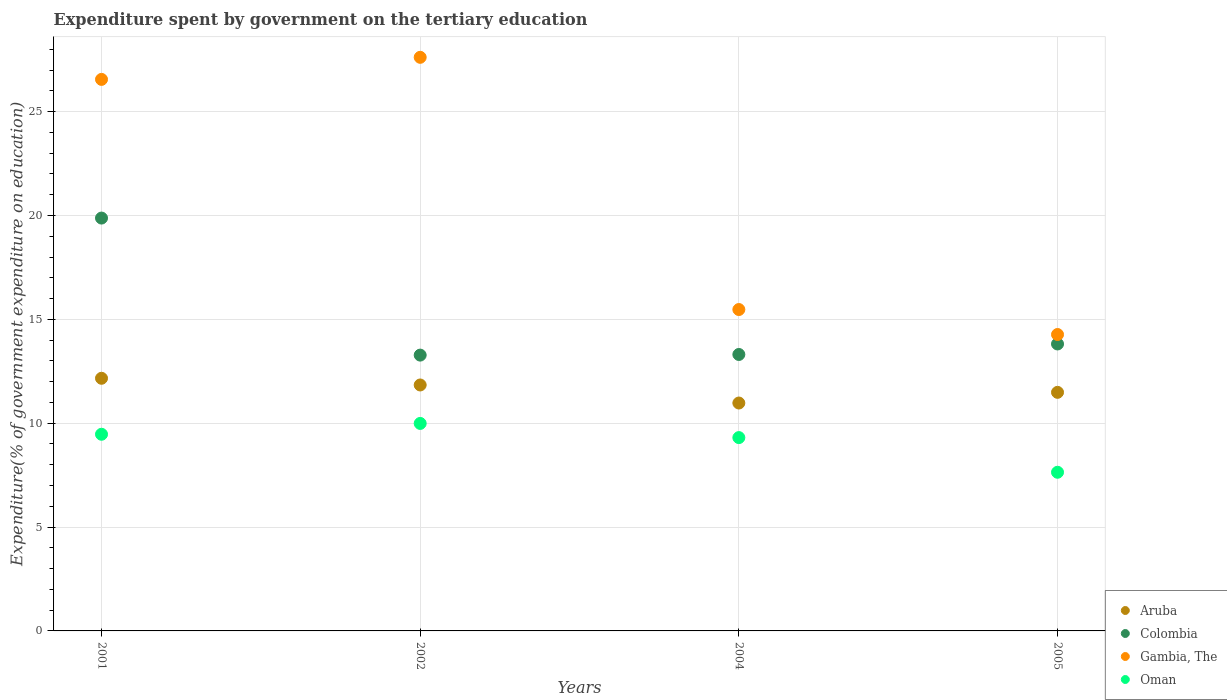How many different coloured dotlines are there?
Ensure brevity in your answer.  4. Is the number of dotlines equal to the number of legend labels?
Offer a terse response. Yes. What is the expenditure spent by government on the tertiary education in Colombia in 2002?
Keep it short and to the point. 13.28. Across all years, what is the maximum expenditure spent by government on the tertiary education in Gambia, The?
Offer a very short reply. 27.61. Across all years, what is the minimum expenditure spent by government on the tertiary education in Colombia?
Make the answer very short. 13.28. In which year was the expenditure spent by government on the tertiary education in Colombia minimum?
Make the answer very short. 2002. What is the total expenditure spent by government on the tertiary education in Colombia in the graph?
Ensure brevity in your answer.  60.27. What is the difference between the expenditure spent by government on the tertiary education in Gambia, The in 2001 and that in 2002?
Provide a succinct answer. -1.06. What is the difference between the expenditure spent by government on the tertiary education in Gambia, The in 2004 and the expenditure spent by government on the tertiary education in Colombia in 2001?
Your answer should be compact. -4.4. What is the average expenditure spent by government on the tertiary education in Colombia per year?
Make the answer very short. 15.07. In the year 2005, what is the difference between the expenditure spent by government on the tertiary education in Aruba and expenditure spent by government on the tertiary education in Gambia, The?
Give a very brief answer. -2.78. In how many years, is the expenditure spent by government on the tertiary education in Aruba greater than 14 %?
Your response must be concise. 0. What is the ratio of the expenditure spent by government on the tertiary education in Colombia in 2004 to that in 2005?
Make the answer very short. 0.96. Is the expenditure spent by government on the tertiary education in Gambia, The in 2004 less than that in 2005?
Offer a very short reply. No. Is the difference between the expenditure spent by government on the tertiary education in Aruba in 2001 and 2004 greater than the difference between the expenditure spent by government on the tertiary education in Gambia, The in 2001 and 2004?
Your answer should be compact. No. What is the difference between the highest and the second highest expenditure spent by government on the tertiary education in Aruba?
Give a very brief answer. 0.32. What is the difference between the highest and the lowest expenditure spent by government on the tertiary education in Oman?
Make the answer very short. 2.35. Is the sum of the expenditure spent by government on the tertiary education in Oman in 2001 and 2002 greater than the maximum expenditure spent by government on the tertiary education in Colombia across all years?
Keep it short and to the point. No. Is it the case that in every year, the sum of the expenditure spent by government on the tertiary education in Colombia and expenditure spent by government on the tertiary education in Oman  is greater than the sum of expenditure spent by government on the tertiary education in Gambia, The and expenditure spent by government on the tertiary education in Aruba?
Your answer should be very brief. No. Is it the case that in every year, the sum of the expenditure spent by government on the tertiary education in Colombia and expenditure spent by government on the tertiary education in Gambia, The  is greater than the expenditure spent by government on the tertiary education in Aruba?
Your answer should be compact. Yes. Does the expenditure spent by government on the tertiary education in Colombia monotonically increase over the years?
Give a very brief answer. No. Is the expenditure spent by government on the tertiary education in Gambia, The strictly less than the expenditure spent by government on the tertiary education in Oman over the years?
Keep it short and to the point. No. How many dotlines are there?
Provide a short and direct response. 4. How many years are there in the graph?
Offer a very short reply. 4. Are the values on the major ticks of Y-axis written in scientific E-notation?
Provide a succinct answer. No. Does the graph contain any zero values?
Offer a terse response. No. Where does the legend appear in the graph?
Your answer should be very brief. Bottom right. How many legend labels are there?
Your response must be concise. 4. What is the title of the graph?
Provide a short and direct response. Expenditure spent by government on the tertiary education. Does "Mali" appear as one of the legend labels in the graph?
Keep it short and to the point. No. What is the label or title of the Y-axis?
Offer a terse response. Expenditure(% of government expenditure on education). What is the Expenditure(% of government expenditure on education) in Aruba in 2001?
Your response must be concise. 12.16. What is the Expenditure(% of government expenditure on education) of Colombia in 2001?
Provide a short and direct response. 19.87. What is the Expenditure(% of government expenditure on education) in Gambia, The in 2001?
Your answer should be very brief. 26.55. What is the Expenditure(% of government expenditure on education) in Oman in 2001?
Offer a very short reply. 9.47. What is the Expenditure(% of government expenditure on education) of Aruba in 2002?
Offer a very short reply. 11.84. What is the Expenditure(% of government expenditure on education) of Colombia in 2002?
Provide a succinct answer. 13.28. What is the Expenditure(% of government expenditure on education) of Gambia, The in 2002?
Provide a short and direct response. 27.61. What is the Expenditure(% of government expenditure on education) of Oman in 2002?
Your answer should be compact. 9.99. What is the Expenditure(% of government expenditure on education) of Aruba in 2004?
Your answer should be compact. 10.97. What is the Expenditure(% of government expenditure on education) in Colombia in 2004?
Ensure brevity in your answer.  13.31. What is the Expenditure(% of government expenditure on education) in Gambia, The in 2004?
Offer a terse response. 15.47. What is the Expenditure(% of government expenditure on education) of Oman in 2004?
Provide a succinct answer. 9.31. What is the Expenditure(% of government expenditure on education) of Aruba in 2005?
Keep it short and to the point. 11.49. What is the Expenditure(% of government expenditure on education) of Colombia in 2005?
Provide a short and direct response. 13.81. What is the Expenditure(% of government expenditure on education) in Gambia, The in 2005?
Offer a very short reply. 14.27. What is the Expenditure(% of government expenditure on education) in Oman in 2005?
Ensure brevity in your answer.  7.64. Across all years, what is the maximum Expenditure(% of government expenditure on education) in Aruba?
Ensure brevity in your answer.  12.16. Across all years, what is the maximum Expenditure(% of government expenditure on education) of Colombia?
Give a very brief answer. 19.87. Across all years, what is the maximum Expenditure(% of government expenditure on education) of Gambia, The?
Give a very brief answer. 27.61. Across all years, what is the maximum Expenditure(% of government expenditure on education) in Oman?
Keep it short and to the point. 9.99. Across all years, what is the minimum Expenditure(% of government expenditure on education) of Aruba?
Provide a short and direct response. 10.97. Across all years, what is the minimum Expenditure(% of government expenditure on education) in Colombia?
Your response must be concise. 13.28. Across all years, what is the minimum Expenditure(% of government expenditure on education) of Gambia, The?
Your answer should be compact. 14.27. Across all years, what is the minimum Expenditure(% of government expenditure on education) of Oman?
Provide a short and direct response. 7.64. What is the total Expenditure(% of government expenditure on education) of Aruba in the graph?
Give a very brief answer. 46.46. What is the total Expenditure(% of government expenditure on education) of Colombia in the graph?
Provide a short and direct response. 60.27. What is the total Expenditure(% of government expenditure on education) of Gambia, The in the graph?
Your answer should be very brief. 83.91. What is the total Expenditure(% of government expenditure on education) in Oman in the graph?
Ensure brevity in your answer.  36.4. What is the difference between the Expenditure(% of government expenditure on education) in Aruba in 2001 and that in 2002?
Provide a succinct answer. 0.32. What is the difference between the Expenditure(% of government expenditure on education) of Colombia in 2001 and that in 2002?
Your answer should be very brief. 6.6. What is the difference between the Expenditure(% of government expenditure on education) in Gambia, The in 2001 and that in 2002?
Ensure brevity in your answer.  -1.06. What is the difference between the Expenditure(% of government expenditure on education) of Oman in 2001 and that in 2002?
Offer a very short reply. -0.52. What is the difference between the Expenditure(% of government expenditure on education) in Aruba in 2001 and that in 2004?
Keep it short and to the point. 1.19. What is the difference between the Expenditure(% of government expenditure on education) in Colombia in 2001 and that in 2004?
Offer a very short reply. 6.57. What is the difference between the Expenditure(% of government expenditure on education) in Gambia, The in 2001 and that in 2004?
Your response must be concise. 11.08. What is the difference between the Expenditure(% of government expenditure on education) of Oman in 2001 and that in 2004?
Your response must be concise. 0.16. What is the difference between the Expenditure(% of government expenditure on education) of Aruba in 2001 and that in 2005?
Ensure brevity in your answer.  0.68. What is the difference between the Expenditure(% of government expenditure on education) of Colombia in 2001 and that in 2005?
Your answer should be very brief. 6.06. What is the difference between the Expenditure(% of government expenditure on education) of Gambia, The in 2001 and that in 2005?
Keep it short and to the point. 12.28. What is the difference between the Expenditure(% of government expenditure on education) in Oman in 2001 and that in 2005?
Your answer should be compact. 1.83. What is the difference between the Expenditure(% of government expenditure on education) of Aruba in 2002 and that in 2004?
Give a very brief answer. 0.87. What is the difference between the Expenditure(% of government expenditure on education) in Colombia in 2002 and that in 2004?
Keep it short and to the point. -0.03. What is the difference between the Expenditure(% of government expenditure on education) in Gambia, The in 2002 and that in 2004?
Keep it short and to the point. 12.14. What is the difference between the Expenditure(% of government expenditure on education) in Oman in 2002 and that in 2004?
Ensure brevity in your answer.  0.68. What is the difference between the Expenditure(% of government expenditure on education) in Aruba in 2002 and that in 2005?
Give a very brief answer. 0.35. What is the difference between the Expenditure(% of government expenditure on education) in Colombia in 2002 and that in 2005?
Make the answer very short. -0.54. What is the difference between the Expenditure(% of government expenditure on education) in Gambia, The in 2002 and that in 2005?
Keep it short and to the point. 13.34. What is the difference between the Expenditure(% of government expenditure on education) of Oman in 2002 and that in 2005?
Give a very brief answer. 2.35. What is the difference between the Expenditure(% of government expenditure on education) of Aruba in 2004 and that in 2005?
Your answer should be very brief. -0.51. What is the difference between the Expenditure(% of government expenditure on education) of Colombia in 2004 and that in 2005?
Give a very brief answer. -0.51. What is the difference between the Expenditure(% of government expenditure on education) in Gambia, The in 2004 and that in 2005?
Your answer should be compact. 1.2. What is the difference between the Expenditure(% of government expenditure on education) in Oman in 2004 and that in 2005?
Keep it short and to the point. 1.67. What is the difference between the Expenditure(% of government expenditure on education) of Aruba in 2001 and the Expenditure(% of government expenditure on education) of Colombia in 2002?
Provide a short and direct response. -1.12. What is the difference between the Expenditure(% of government expenditure on education) in Aruba in 2001 and the Expenditure(% of government expenditure on education) in Gambia, The in 2002?
Keep it short and to the point. -15.45. What is the difference between the Expenditure(% of government expenditure on education) of Aruba in 2001 and the Expenditure(% of government expenditure on education) of Oman in 2002?
Offer a terse response. 2.17. What is the difference between the Expenditure(% of government expenditure on education) of Colombia in 2001 and the Expenditure(% of government expenditure on education) of Gambia, The in 2002?
Keep it short and to the point. -7.74. What is the difference between the Expenditure(% of government expenditure on education) of Colombia in 2001 and the Expenditure(% of government expenditure on education) of Oman in 2002?
Make the answer very short. 9.89. What is the difference between the Expenditure(% of government expenditure on education) in Gambia, The in 2001 and the Expenditure(% of government expenditure on education) in Oman in 2002?
Your answer should be very brief. 16.56. What is the difference between the Expenditure(% of government expenditure on education) of Aruba in 2001 and the Expenditure(% of government expenditure on education) of Colombia in 2004?
Offer a very short reply. -1.15. What is the difference between the Expenditure(% of government expenditure on education) in Aruba in 2001 and the Expenditure(% of government expenditure on education) in Gambia, The in 2004?
Offer a very short reply. -3.31. What is the difference between the Expenditure(% of government expenditure on education) of Aruba in 2001 and the Expenditure(% of government expenditure on education) of Oman in 2004?
Your response must be concise. 2.86. What is the difference between the Expenditure(% of government expenditure on education) in Colombia in 2001 and the Expenditure(% of government expenditure on education) in Gambia, The in 2004?
Provide a short and direct response. 4.4. What is the difference between the Expenditure(% of government expenditure on education) of Colombia in 2001 and the Expenditure(% of government expenditure on education) of Oman in 2004?
Your response must be concise. 10.57. What is the difference between the Expenditure(% of government expenditure on education) in Gambia, The in 2001 and the Expenditure(% of government expenditure on education) in Oman in 2004?
Keep it short and to the point. 17.24. What is the difference between the Expenditure(% of government expenditure on education) in Aruba in 2001 and the Expenditure(% of government expenditure on education) in Colombia in 2005?
Ensure brevity in your answer.  -1.65. What is the difference between the Expenditure(% of government expenditure on education) in Aruba in 2001 and the Expenditure(% of government expenditure on education) in Gambia, The in 2005?
Provide a short and direct response. -2.11. What is the difference between the Expenditure(% of government expenditure on education) in Aruba in 2001 and the Expenditure(% of government expenditure on education) in Oman in 2005?
Keep it short and to the point. 4.52. What is the difference between the Expenditure(% of government expenditure on education) in Colombia in 2001 and the Expenditure(% of government expenditure on education) in Gambia, The in 2005?
Ensure brevity in your answer.  5.61. What is the difference between the Expenditure(% of government expenditure on education) in Colombia in 2001 and the Expenditure(% of government expenditure on education) in Oman in 2005?
Make the answer very short. 12.24. What is the difference between the Expenditure(% of government expenditure on education) of Gambia, The in 2001 and the Expenditure(% of government expenditure on education) of Oman in 2005?
Offer a terse response. 18.91. What is the difference between the Expenditure(% of government expenditure on education) in Aruba in 2002 and the Expenditure(% of government expenditure on education) in Colombia in 2004?
Make the answer very short. -1.47. What is the difference between the Expenditure(% of government expenditure on education) in Aruba in 2002 and the Expenditure(% of government expenditure on education) in Gambia, The in 2004?
Give a very brief answer. -3.63. What is the difference between the Expenditure(% of government expenditure on education) in Aruba in 2002 and the Expenditure(% of government expenditure on education) in Oman in 2004?
Ensure brevity in your answer.  2.53. What is the difference between the Expenditure(% of government expenditure on education) in Colombia in 2002 and the Expenditure(% of government expenditure on education) in Gambia, The in 2004?
Make the answer very short. -2.19. What is the difference between the Expenditure(% of government expenditure on education) of Colombia in 2002 and the Expenditure(% of government expenditure on education) of Oman in 2004?
Provide a short and direct response. 3.97. What is the difference between the Expenditure(% of government expenditure on education) in Gambia, The in 2002 and the Expenditure(% of government expenditure on education) in Oman in 2004?
Your answer should be compact. 18.31. What is the difference between the Expenditure(% of government expenditure on education) in Aruba in 2002 and the Expenditure(% of government expenditure on education) in Colombia in 2005?
Offer a very short reply. -1.97. What is the difference between the Expenditure(% of government expenditure on education) of Aruba in 2002 and the Expenditure(% of government expenditure on education) of Gambia, The in 2005?
Your response must be concise. -2.43. What is the difference between the Expenditure(% of government expenditure on education) of Aruba in 2002 and the Expenditure(% of government expenditure on education) of Oman in 2005?
Give a very brief answer. 4.2. What is the difference between the Expenditure(% of government expenditure on education) of Colombia in 2002 and the Expenditure(% of government expenditure on education) of Gambia, The in 2005?
Offer a terse response. -0.99. What is the difference between the Expenditure(% of government expenditure on education) in Colombia in 2002 and the Expenditure(% of government expenditure on education) in Oman in 2005?
Provide a short and direct response. 5.64. What is the difference between the Expenditure(% of government expenditure on education) in Gambia, The in 2002 and the Expenditure(% of government expenditure on education) in Oman in 2005?
Offer a terse response. 19.98. What is the difference between the Expenditure(% of government expenditure on education) in Aruba in 2004 and the Expenditure(% of government expenditure on education) in Colombia in 2005?
Ensure brevity in your answer.  -2.84. What is the difference between the Expenditure(% of government expenditure on education) in Aruba in 2004 and the Expenditure(% of government expenditure on education) in Gambia, The in 2005?
Provide a succinct answer. -3.3. What is the difference between the Expenditure(% of government expenditure on education) in Aruba in 2004 and the Expenditure(% of government expenditure on education) in Oman in 2005?
Your answer should be compact. 3.33. What is the difference between the Expenditure(% of government expenditure on education) in Colombia in 2004 and the Expenditure(% of government expenditure on education) in Gambia, The in 2005?
Offer a terse response. -0.96. What is the difference between the Expenditure(% of government expenditure on education) in Colombia in 2004 and the Expenditure(% of government expenditure on education) in Oman in 2005?
Keep it short and to the point. 5.67. What is the difference between the Expenditure(% of government expenditure on education) of Gambia, The in 2004 and the Expenditure(% of government expenditure on education) of Oman in 2005?
Offer a terse response. 7.83. What is the average Expenditure(% of government expenditure on education) in Aruba per year?
Give a very brief answer. 11.61. What is the average Expenditure(% of government expenditure on education) in Colombia per year?
Your answer should be very brief. 15.07. What is the average Expenditure(% of government expenditure on education) in Gambia, The per year?
Ensure brevity in your answer.  20.98. What is the average Expenditure(% of government expenditure on education) in Oman per year?
Offer a terse response. 9.1. In the year 2001, what is the difference between the Expenditure(% of government expenditure on education) of Aruba and Expenditure(% of government expenditure on education) of Colombia?
Give a very brief answer. -7.71. In the year 2001, what is the difference between the Expenditure(% of government expenditure on education) in Aruba and Expenditure(% of government expenditure on education) in Gambia, The?
Offer a terse response. -14.39. In the year 2001, what is the difference between the Expenditure(% of government expenditure on education) in Aruba and Expenditure(% of government expenditure on education) in Oman?
Offer a terse response. 2.69. In the year 2001, what is the difference between the Expenditure(% of government expenditure on education) in Colombia and Expenditure(% of government expenditure on education) in Gambia, The?
Give a very brief answer. -6.68. In the year 2001, what is the difference between the Expenditure(% of government expenditure on education) of Colombia and Expenditure(% of government expenditure on education) of Oman?
Your answer should be compact. 10.41. In the year 2001, what is the difference between the Expenditure(% of government expenditure on education) in Gambia, The and Expenditure(% of government expenditure on education) in Oman?
Your answer should be very brief. 17.08. In the year 2002, what is the difference between the Expenditure(% of government expenditure on education) in Aruba and Expenditure(% of government expenditure on education) in Colombia?
Offer a terse response. -1.44. In the year 2002, what is the difference between the Expenditure(% of government expenditure on education) of Aruba and Expenditure(% of government expenditure on education) of Gambia, The?
Provide a succinct answer. -15.77. In the year 2002, what is the difference between the Expenditure(% of government expenditure on education) of Aruba and Expenditure(% of government expenditure on education) of Oman?
Make the answer very short. 1.85. In the year 2002, what is the difference between the Expenditure(% of government expenditure on education) in Colombia and Expenditure(% of government expenditure on education) in Gambia, The?
Offer a very short reply. -14.34. In the year 2002, what is the difference between the Expenditure(% of government expenditure on education) of Colombia and Expenditure(% of government expenditure on education) of Oman?
Provide a short and direct response. 3.29. In the year 2002, what is the difference between the Expenditure(% of government expenditure on education) of Gambia, The and Expenditure(% of government expenditure on education) of Oman?
Give a very brief answer. 17.62. In the year 2004, what is the difference between the Expenditure(% of government expenditure on education) of Aruba and Expenditure(% of government expenditure on education) of Colombia?
Keep it short and to the point. -2.34. In the year 2004, what is the difference between the Expenditure(% of government expenditure on education) in Aruba and Expenditure(% of government expenditure on education) in Gambia, The?
Provide a succinct answer. -4.5. In the year 2004, what is the difference between the Expenditure(% of government expenditure on education) in Aruba and Expenditure(% of government expenditure on education) in Oman?
Ensure brevity in your answer.  1.66. In the year 2004, what is the difference between the Expenditure(% of government expenditure on education) of Colombia and Expenditure(% of government expenditure on education) of Gambia, The?
Give a very brief answer. -2.16. In the year 2004, what is the difference between the Expenditure(% of government expenditure on education) in Colombia and Expenditure(% of government expenditure on education) in Oman?
Offer a terse response. 4. In the year 2004, what is the difference between the Expenditure(% of government expenditure on education) in Gambia, The and Expenditure(% of government expenditure on education) in Oman?
Offer a terse response. 6.17. In the year 2005, what is the difference between the Expenditure(% of government expenditure on education) of Aruba and Expenditure(% of government expenditure on education) of Colombia?
Offer a very short reply. -2.33. In the year 2005, what is the difference between the Expenditure(% of government expenditure on education) in Aruba and Expenditure(% of government expenditure on education) in Gambia, The?
Your answer should be compact. -2.78. In the year 2005, what is the difference between the Expenditure(% of government expenditure on education) of Aruba and Expenditure(% of government expenditure on education) of Oman?
Provide a short and direct response. 3.85. In the year 2005, what is the difference between the Expenditure(% of government expenditure on education) in Colombia and Expenditure(% of government expenditure on education) in Gambia, The?
Offer a very short reply. -0.46. In the year 2005, what is the difference between the Expenditure(% of government expenditure on education) of Colombia and Expenditure(% of government expenditure on education) of Oman?
Make the answer very short. 6.18. In the year 2005, what is the difference between the Expenditure(% of government expenditure on education) of Gambia, The and Expenditure(% of government expenditure on education) of Oman?
Provide a succinct answer. 6.63. What is the ratio of the Expenditure(% of government expenditure on education) of Aruba in 2001 to that in 2002?
Offer a very short reply. 1.03. What is the ratio of the Expenditure(% of government expenditure on education) of Colombia in 2001 to that in 2002?
Ensure brevity in your answer.  1.5. What is the ratio of the Expenditure(% of government expenditure on education) of Gambia, The in 2001 to that in 2002?
Offer a terse response. 0.96. What is the ratio of the Expenditure(% of government expenditure on education) of Oman in 2001 to that in 2002?
Offer a terse response. 0.95. What is the ratio of the Expenditure(% of government expenditure on education) in Aruba in 2001 to that in 2004?
Your answer should be compact. 1.11. What is the ratio of the Expenditure(% of government expenditure on education) in Colombia in 2001 to that in 2004?
Offer a terse response. 1.49. What is the ratio of the Expenditure(% of government expenditure on education) of Gambia, The in 2001 to that in 2004?
Keep it short and to the point. 1.72. What is the ratio of the Expenditure(% of government expenditure on education) in Oman in 2001 to that in 2004?
Your response must be concise. 1.02. What is the ratio of the Expenditure(% of government expenditure on education) of Aruba in 2001 to that in 2005?
Your answer should be compact. 1.06. What is the ratio of the Expenditure(% of government expenditure on education) in Colombia in 2001 to that in 2005?
Give a very brief answer. 1.44. What is the ratio of the Expenditure(% of government expenditure on education) in Gambia, The in 2001 to that in 2005?
Make the answer very short. 1.86. What is the ratio of the Expenditure(% of government expenditure on education) of Oman in 2001 to that in 2005?
Provide a short and direct response. 1.24. What is the ratio of the Expenditure(% of government expenditure on education) in Aruba in 2002 to that in 2004?
Your response must be concise. 1.08. What is the ratio of the Expenditure(% of government expenditure on education) in Gambia, The in 2002 to that in 2004?
Your response must be concise. 1.78. What is the ratio of the Expenditure(% of government expenditure on education) of Oman in 2002 to that in 2004?
Keep it short and to the point. 1.07. What is the ratio of the Expenditure(% of government expenditure on education) of Aruba in 2002 to that in 2005?
Provide a short and direct response. 1.03. What is the ratio of the Expenditure(% of government expenditure on education) of Colombia in 2002 to that in 2005?
Offer a very short reply. 0.96. What is the ratio of the Expenditure(% of government expenditure on education) in Gambia, The in 2002 to that in 2005?
Provide a succinct answer. 1.94. What is the ratio of the Expenditure(% of government expenditure on education) of Oman in 2002 to that in 2005?
Provide a succinct answer. 1.31. What is the ratio of the Expenditure(% of government expenditure on education) in Aruba in 2004 to that in 2005?
Give a very brief answer. 0.96. What is the ratio of the Expenditure(% of government expenditure on education) in Colombia in 2004 to that in 2005?
Offer a very short reply. 0.96. What is the ratio of the Expenditure(% of government expenditure on education) in Gambia, The in 2004 to that in 2005?
Provide a succinct answer. 1.08. What is the ratio of the Expenditure(% of government expenditure on education) of Oman in 2004 to that in 2005?
Ensure brevity in your answer.  1.22. What is the difference between the highest and the second highest Expenditure(% of government expenditure on education) in Aruba?
Provide a short and direct response. 0.32. What is the difference between the highest and the second highest Expenditure(% of government expenditure on education) in Colombia?
Provide a short and direct response. 6.06. What is the difference between the highest and the second highest Expenditure(% of government expenditure on education) of Gambia, The?
Your answer should be very brief. 1.06. What is the difference between the highest and the second highest Expenditure(% of government expenditure on education) of Oman?
Ensure brevity in your answer.  0.52. What is the difference between the highest and the lowest Expenditure(% of government expenditure on education) in Aruba?
Make the answer very short. 1.19. What is the difference between the highest and the lowest Expenditure(% of government expenditure on education) of Colombia?
Give a very brief answer. 6.6. What is the difference between the highest and the lowest Expenditure(% of government expenditure on education) in Gambia, The?
Offer a very short reply. 13.34. What is the difference between the highest and the lowest Expenditure(% of government expenditure on education) of Oman?
Provide a succinct answer. 2.35. 